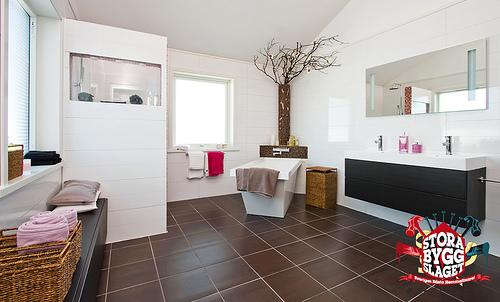Does the room look tidy?
Concise answer only. Yes. Is the tree dead?
Give a very brief answer. Yes. How many windows are there?
Quick response, please. 2. Is this a wide-angle perspective?
Write a very short answer. Yes. Where are the plants?
Short answer required. Corner. 